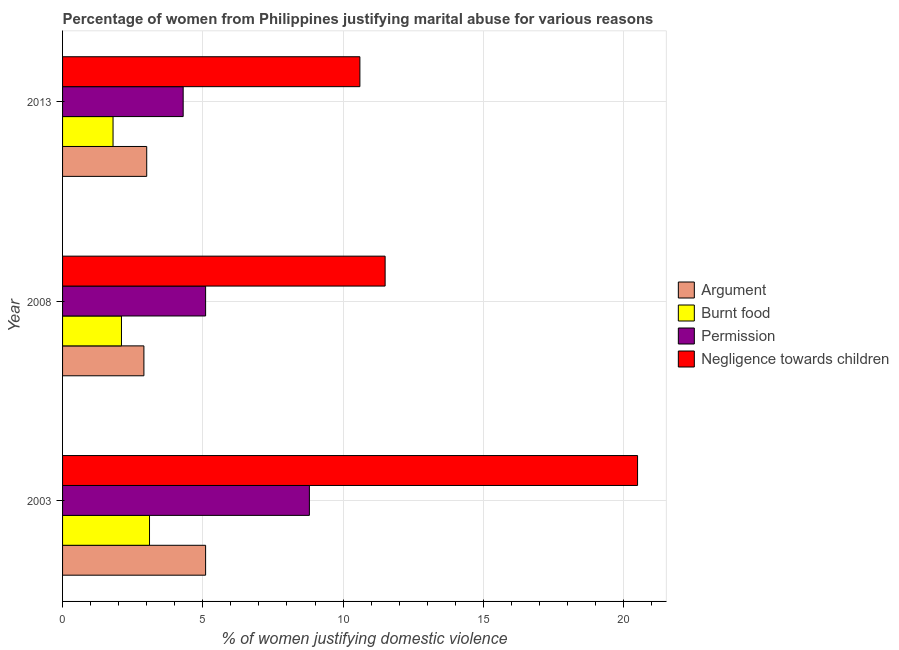Are the number of bars on each tick of the Y-axis equal?
Make the answer very short. Yes. How many bars are there on the 2nd tick from the top?
Provide a succinct answer. 4. How many bars are there on the 1st tick from the bottom?
Keep it short and to the point. 4. What is the label of the 1st group of bars from the top?
Your answer should be compact. 2013. In how many cases, is the number of bars for a given year not equal to the number of legend labels?
Ensure brevity in your answer.  0. What is the percentage of women justifying abuse for going without permission in 2003?
Your answer should be compact. 8.8. Across all years, what is the maximum percentage of women justifying abuse in the case of an argument?
Offer a terse response. 5.1. Across all years, what is the minimum percentage of women justifying abuse in the case of an argument?
Your response must be concise. 2.9. What is the total percentage of women justifying abuse for showing negligence towards children in the graph?
Ensure brevity in your answer.  42.6. What is the difference between the percentage of women justifying abuse for showing negligence towards children in 2003 and that in 2013?
Provide a short and direct response. 9.9. What is the difference between the percentage of women justifying abuse for going without permission in 2003 and the percentage of women justifying abuse for burning food in 2008?
Your answer should be very brief. 6.7. What is the average percentage of women justifying abuse for going without permission per year?
Your response must be concise. 6.07. In the year 2003, what is the difference between the percentage of women justifying abuse for burning food and percentage of women justifying abuse for going without permission?
Ensure brevity in your answer.  -5.7. In how many years, is the percentage of women justifying abuse for showing negligence towards children greater than 11 %?
Your response must be concise. 2. What is the ratio of the percentage of women justifying abuse for showing negligence towards children in 2003 to that in 2008?
Provide a succinct answer. 1.78. What is the difference between the highest and the lowest percentage of women justifying abuse for going without permission?
Ensure brevity in your answer.  4.5. Is the sum of the percentage of women justifying abuse in the case of an argument in 2003 and 2013 greater than the maximum percentage of women justifying abuse for showing negligence towards children across all years?
Offer a terse response. No. What does the 3rd bar from the top in 2008 represents?
Your answer should be compact. Burnt food. What does the 2nd bar from the bottom in 2003 represents?
Give a very brief answer. Burnt food. What is the difference between two consecutive major ticks on the X-axis?
Keep it short and to the point. 5. Does the graph contain any zero values?
Give a very brief answer. No. Does the graph contain grids?
Offer a very short reply. Yes. Where does the legend appear in the graph?
Offer a very short reply. Center right. How many legend labels are there?
Provide a succinct answer. 4. How are the legend labels stacked?
Offer a terse response. Vertical. What is the title of the graph?
Your response must be concise. Percentage of women from Philippines justifying marital abuse for various reasons. What is the label or title of the X-axis?
Your answer should be very brief. % of women justifying domestic violence. What is the label or title of the Y-axis?
Ensure brevity in your answer.  Year. What is the % of women justifying domestic violence in Argument in 2003?
Your response must be concise. 5.1. What is the % of women justifying domestic violence in Burnt food in 2003?
Keep it short and to the point. 3.1. What is the % of women justifying domestic violence of Argument in 2008?
Provide a short and direct response. 2.9. What is the % of women justifying domestic violence of Permission in 2008?
Keep it short and to the point. 5.1. What is the % of women justifying domestic violence of Permission in 2013?
Your answer should be very brief. 4.3. What is the % of women justifying domestic violence in Negligence towards children in 2013?
Your answer should be very brief. 10.6. Across all years, what is the minimum % of women justifying domestic violence in Burnt food?
Keep it short and to the point. 1.8. Across all years, what is the minimum % of women justifying domestic violence in Negligence towards children?
Your response must be concise. 10.6. What is the total % of women justifying domestic violence in Burnt food in the graph?
Keep it short and to the point. 7. What is the total % of women justifying domestic violence of Negligence towards children in the graph?
Offer a terse response. 42.6. What is the difference between the % of women justifying domestic violence of Argument in 2003 and that in 2008?
Ensure brevity in your answer.  2.2. What is the difference between the % of women justifying domestic violence of Burnt food in 2003 and that in 2008?
Your answer should be very brief. 1. What is the difference between the % of women justifying domestic violence in Negligence towards children in 2003 and that in 2008?
Give a very brief answer. 9. What is the difference between the % of women justifying domestic violence in Burnt food in 2003 and that in 2013?
Your response must be concise. 1.3. What is the difference between the % of women justifying domestic violence of Argument in 2008 and that in 2013?
Your response must be concise. -0.1. What is the difference between the % of women justifying domestic violence in Permission in 2008 and that in 2013?
Give a very brief answer. 0.8. What is the difference between the % of women justifying domestic violence of Argument in 2003 and the % of women justifying domestic violence of Burnt food in 2008?
Ensure brevity in your answer.  3. What is the difference between the % of women justifying domestic violence of Argument in 2003 and the % of women justifying domestic violence of Negligence towards children in 2008?
Your response must be concise. -6.4. What is the difference between the % of women justifying domestic violence of Burnt food in 2003 and the % of women justifying domestic violence of Permission in 2013?
Your answer should be very brief. -1.2. What is the difference between the % of women justifying domestic violence in Argument in 2008 and the % of women justifying domestic violence in Burnt food in 2013?
Make the answer very short. 1.1. What is the difference between the % of women justifying domestic violence of Argument in 2008 and the % of women justifying domestic violence of Negligence towards children in 2013?
Your response must be concise. -7.7. What is the difference between the % of women justifying domestic violence in Burnt food in 2008 and the % of women justifying domestic violence in Permission in 2013?
Offer a very short reply. -2.2. What is the average % of women justifying domestic violence in Argument per year?
Provide a succinct answer. 3.67. What is the average % of women justifying domestic violence of Burnt food per year?
Provide a short and direct response. 2.33. What is the average % of women justifying domestic violence in Permission per year?
Offer a very short reply. 6.07. What is the average % of women justifying domestic violence of Negligence towards children per year?
Your response must be concise. 14.2. In the year 2003, what is the difference between the % of women justifying domestic violence in Argument and % of women justifying domestic violence in Burnt food?
Provide a succinct answer. 2. In the year 2003, what is the difference between the % of women justifying domestic violence in Argument and % of women justifying domestic violence in Negligence towards children?
Provide a succinct answer. -15.4. In the year 2003, what is the difference between the % of women justifying domestic violence in Burnt food and % of women justifying domestic violence in Permission?
Your answer should be very brief. -5.7. In the year 2003, what is the difference between the % of women justifying domestic violence of Burnt food and % of women justifying domestic violence of Negligence towards children?
Ensure brevity in your answer.  -17.4. In the year 2008, what is the difference between the % of women justifying domestic violence in Argument and % of women justifying domestic violence in Burnt food?
Make the answer very short. 0.8. In the year 2008, what is the difference between the % of women justifying domestic violence in Argument and % of women justifying domestic violence in Permission?
Your answer should be very brief. -2.2. In the year 2008, what is the difference between the % of women justifying domestic violence in Burnt food and % of women justifying domestic violence in Permission?
Offer a very short reply. -3. In the year 2008, what is the difference between the % of women justifying domestic violence in Burnt food and % of women justifying domestic violence in Negligence towards children?
Your answer should be compact. -9.4. In the year 2013, what is the difference between the % of women justifying domestic violence of Argument and % of women justifying domestic violence of Burnt food?
Ensure brevity in your answer.  1.2. In the year 2013, what is the difference between the % of women justifying domestic violence of Argument and % of women justifying domestic violence of Permission?
Keep it short and to the point. -1.3. In the year 2013, what is the difference between the % of women justifying domestic violence of Burnt food and % of women justifying domestic violence of Negligence towards children?
Your response must be concise. -8.8. In the year 2013, what is the difference between the % of women justifying domestic violence of Permission and % of women justifying domestic violence of Negligence towards children?
Provide a succinct answer. -6.3. What is the ratio of the % of women justifying domestic violence in Argument in 2003 to that in 2008?
Your answer should be very brief. 1.76. What is the ratio of the % of women justifying domestic violence in Burnt food in 2003 to that in 2008?
Give a very brief answer. 1.48. What is the ratio of the % of women justifying domestic violence in Permission in 2003 to that in 2008?
Offer a terse response. 1.73. What is the ratio of the % of women justifying domestic violence of Negligence towards children in 2003 to that in 2008?
Give a very brief answer. 1.78. What is the ratio of the % of women justifying domestic violence in Argument in 2003 to that in 2013?
Offer a very short reply. 1.7. What is the ratio of the % of women justifying domestic violence of Burnt food in 2003 to that in 2013?
Offer a very short reply. 1.72. What is the ratio of the % of women justifying domestic violence in Permission in 2003 to that in 2013?
Your response must be concise. 2.05. What is the ratio of the % of women justifying domestic violence in Negligence towards children in 2003 to that in 2013?
Provide a succinct answer. 1.93. What is the ratio of the % of women justifying domestic violence of Argument in 2008 to that in 2013?
Your response must be concise. 0.97. What is the ratio of the % of women justifying domestic violence in Permission in 2008 to that in 2013?
Your response must be concise. 1.19. What is the ratio of the % of women justifying domestic violence of Negligence towards children in 2008 to that in 2013?
Your answer should be very brief. 1.08. What is the difference between the highest and the second highest % of women justifying domestic violence in Burnt food?
Give a very brief answer. 1. What is the difference between the highest and the second highest % of women justifying domestic violence in Permission?
Offer a terse response. 3.7. What is the difference between the highest and the lowest % of women justifying domestic violence of Argument?
Offer a terse response. 2.2. What is the difference between the highest and the lowest % of women justifying domestic violence of Burnt food?
Ensure brevity in your answer.  1.3. What is the difference between the highest and the lowest % of women justifying domestic violence of Permission?
Keep it short and to the point. 4.5. 